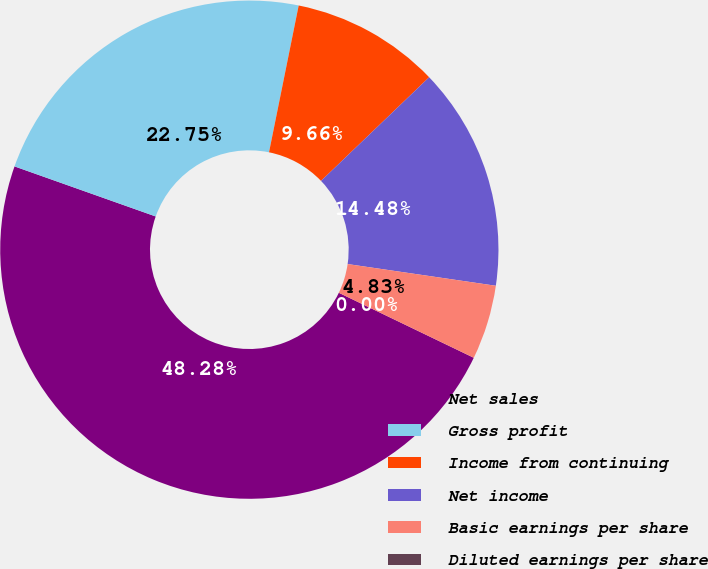Convert chart. <chart><loc_0><loc_0><loc_500><loc_500><pie_chart><fcel>Net sales<fcel>Gross profit<fcel>Income from continuing<fcel>Net income<fcel>Basic earnings per share<fcel>Diluted earnings per share<nl><fcel>48.28%<fcel>22.75%<fcel>9.66%<fcel>14.48%<fcel>4.83%<fcel>0.0%<nl></chart> 